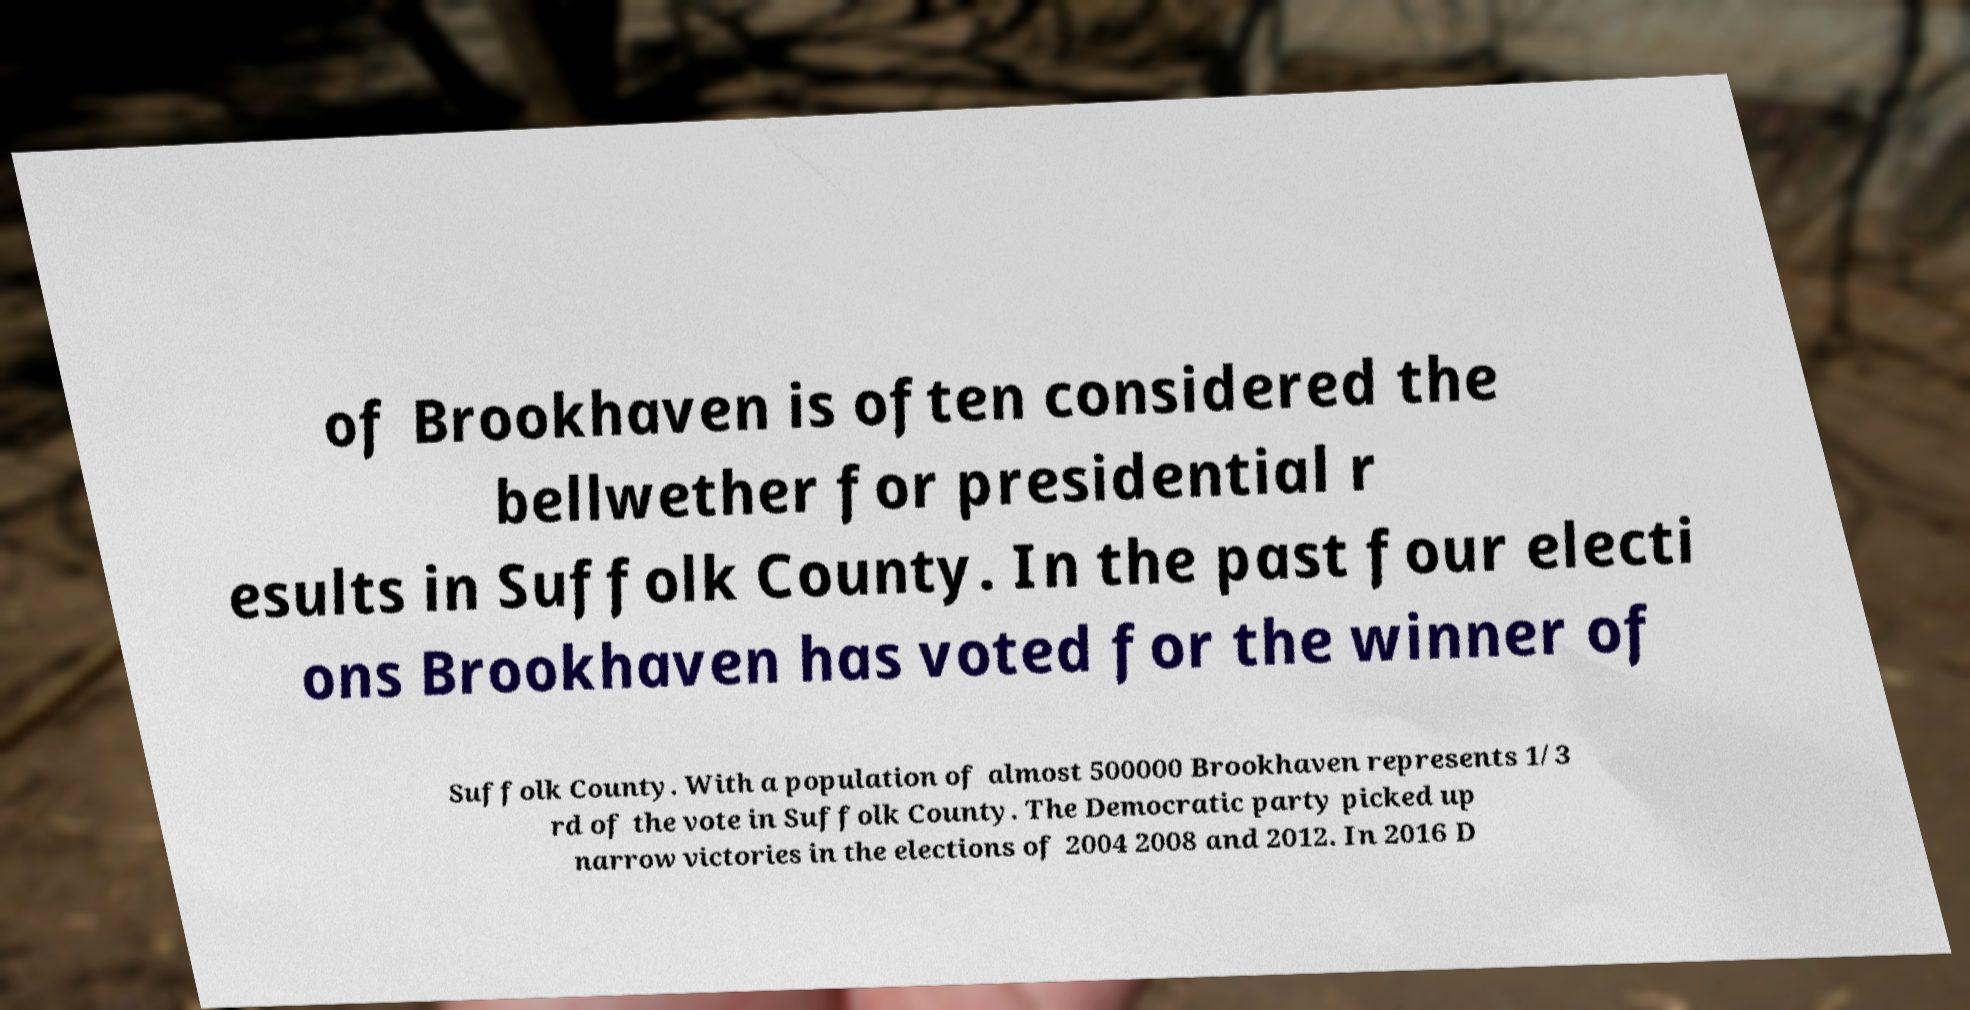Could you extract and type out the text from this image? of Brookhaven is often considered the bellwether for presidential r esults in Suffolk County. In the past four electi ons Brookhaven has voted for the winner of Suffolk County. With a population of almost 500000 Brookhaven represents 1/3 rd of the vote in Suffolk County. The Democratic party picked up narrow victories in the elections of 2004 2008 and 2012. In 2016 D 